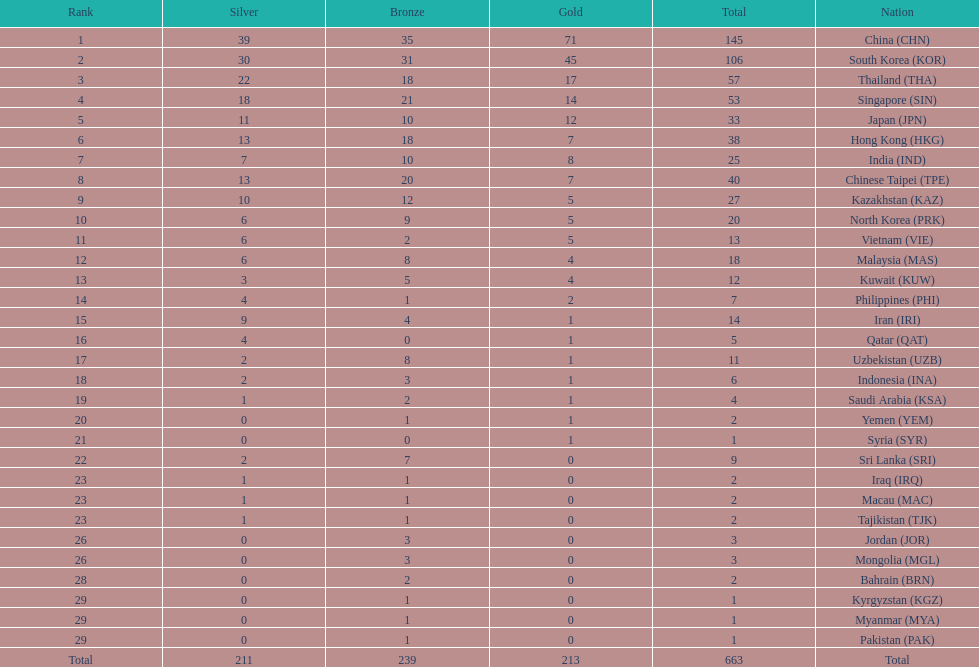In comparison to kuwait, has india secured more gold medals? India (IND). 